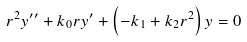Convert formula to latex. <formula><loc_0><loc_0><loc_500><loc_500>r ^ { 2 } y ^ { \prime \prime } + k _ { 0 } r y ^ { \prime } + \left ( - k _ { 1 } + k _ { 2 } r ^ { 2 } \right ) y = 0</formula> 